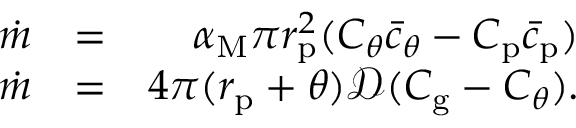Convert formula to latex. <formula><loc_0><loc_0><loc_500><loc_500>\begin{array} { r l r } { \dot { m } } & { = } & { \alpha _ { M } \pi r _ { p } ^ { 2 } ( C _ { \theta } \bar { c } _ { \theta } - C _ { p } \bar { c } _ { p } ) } \\ { \dot { m } } & { = } & { 4 \pi ( r _ { p } + \theta ) \mathcal { D } ( C _ { g } - C _ { \theta } ) . } \end{array}</formula> 